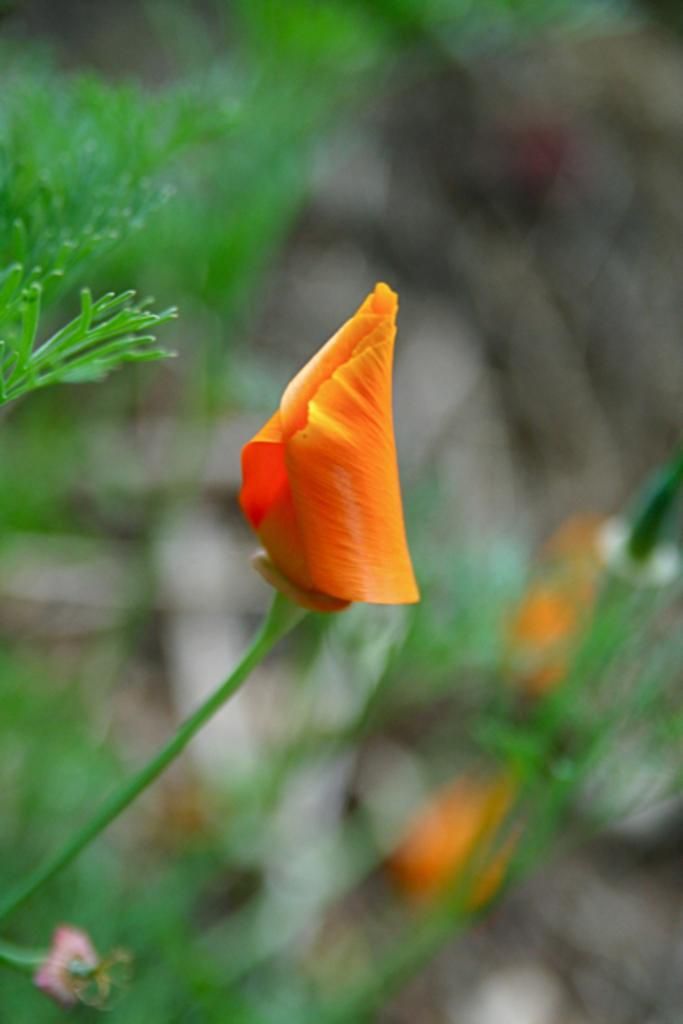What is the main subject of the image? There is a flower in the image. Can you describe the flower in more detail? The flower has a stem. What can be observed about the background of the image? The background of the image is blurry. Can you tell me how many snakes are slithering around the flower in the image? There are no snakes present in the image; it features a flower with a stem and a blurry background. What type of mine is visible in the image? There is no mine present in the image; it features a flower with a stem and a blurry background. 